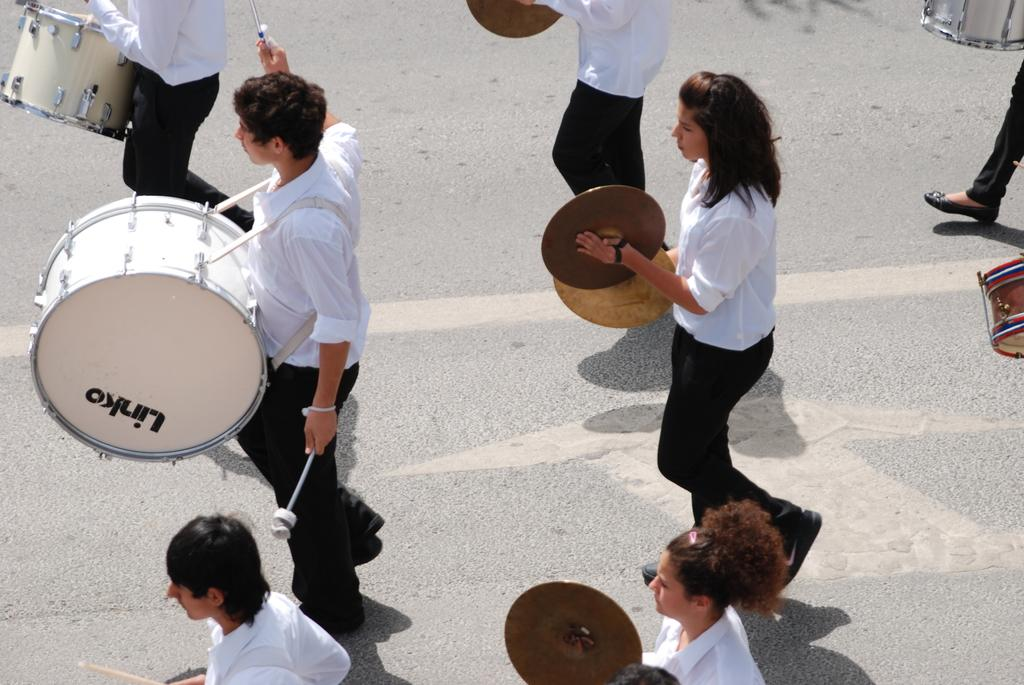What are the people in the image doing? The people in the image are playing musical instruments. Where are the people located in the image? The location of the people is on the road. What type of advertisement can be seen on the side of the road in the image? There is no advertisement visible on the side of the road in the image. What kind of adjustment is being made to the musical instruments in the image? There is no indication in the image that any adjustments are being made to the musical instruments. 